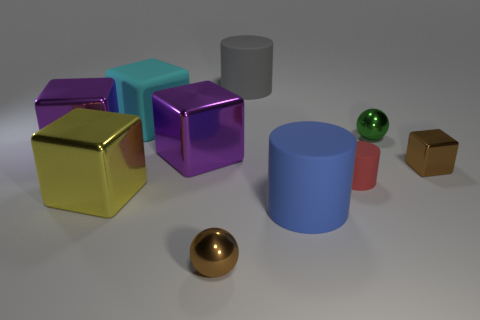How many cyan things have the same size as the green metal sphere?
Give a very brief answer. 0. There is a small object that is the same color as the tiny shiny cube; what is its shape?
Make the answer very short. Sphere. Are there any matte cylinders behind the rubber object to the left of the tiny brown ball?
Provide a succinct answer. Yes. How many things are cylinders that are to the left of the blue cylinder or small matte cylinders?
Your answer should be very brief. 2. How many large blue cylinders are there?
Provide a succinct answer. 1. The green thing that is made of the same material as the large yellow block is what shape?
Provide a short and direct response. Sphere. There is a shiny object right of the tiny object that is behind the brown metallic cube; what size is it?
Provide a short and direct response. Small. What number of things are either small balls behind the brown shiny ball or large cubes that are in front of the brown metal block?
Offer a terse response. 2. Is the number of big gray things less than the number of tiny metal balls?
Offer a terse response. Yes. What number of things are gray things or large blue cylinders?
Provide a succinct answer. 2. 